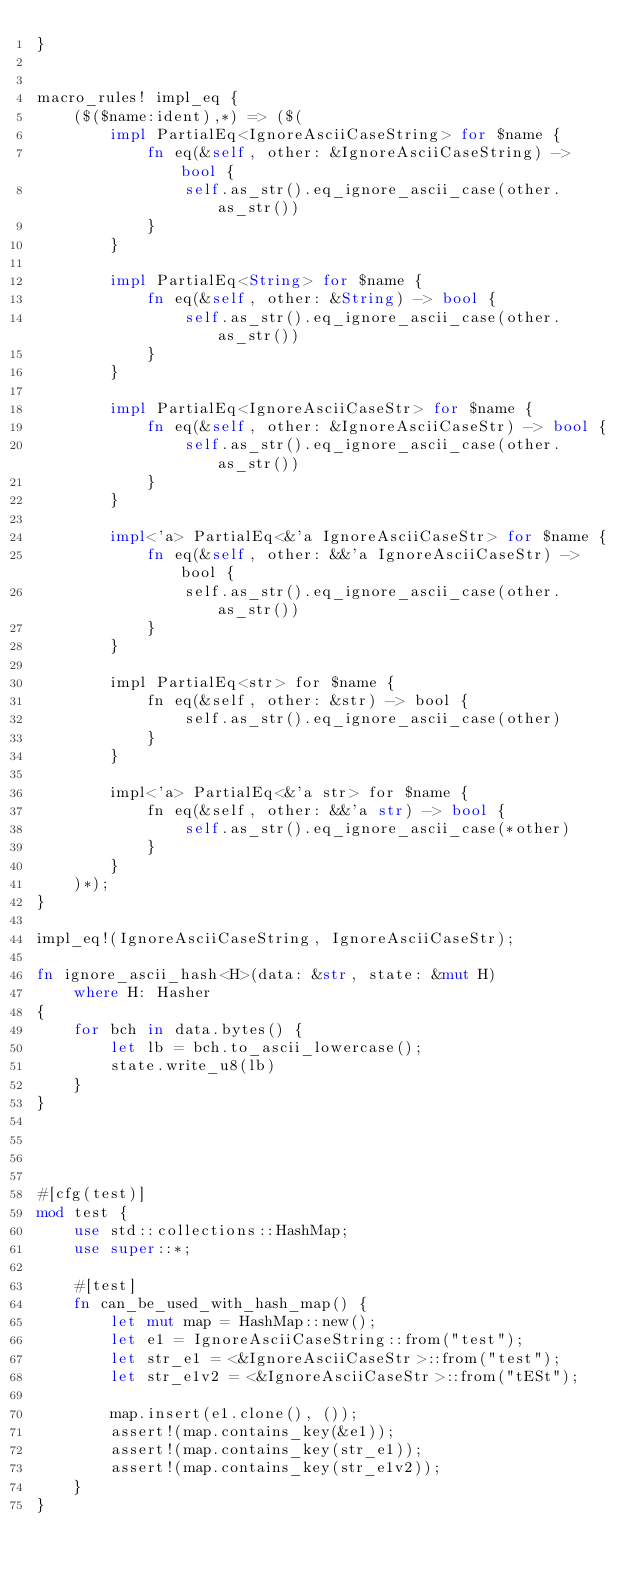Convert code to text. <code><loc_0><loc_0><loc_500><loc_500><_Rust_>}


macro_rules! impl_eq {
    ($($name:ident),*) => ($(
        impl PartialEq<IgnoreAsciiCaseString> for $name {
            fn eq(&self, other: &IgnoreAsciiCaseString) -> bool {
                self.as_str().eq_ignore_ascii_case(other.as_str())
            }
        }

        impl PartialEq<String> for $name {
            fn eq(&self, other: &String) -> bool {
                self.as_str().eq_ignore_ascii_case(other.as_str())
            }
        }

        impl PartialEq<IgnoreAsciiCaseStr> for $name {
            fn eq(&self, other: &IgnoreAsciiCaseStr) -> bool {
                self.as_str().eq_ignore_ascii_case(other.as_str())
            }
        }

        impl<'a> PartialEq<&'a IgnoreAsciiCaseStr> for $name {
            fn eq(&self, other: &&'a IgnoreAsciiCaseStr) -> bool {
                self.as_str().eq_ignore_ascii_case(other.as_str())
            }
        }

        impl PartialEq<str> for $name {
            fn eq(&self, other: &str) -> bool {
                self.as_str().eq_ignore_ascii_case(other)
            }
        }

        impl<'a> PartialEq<&'a str> for $name {
            fn eq(&self, other: &&'a str) -> bool {
                self.as_str().eq_ignore_ascii_case(*other)
            }
        }
    )*);
}

impl_eq!(IgnoreAsciiCaseString, IgnoreAsciiCaseStr);

fn ignore_ascii_hash<H>(data: &str, state: &mut H)
    where H: Hasher
{
    for bch in data.bytes() {
        let lb = bch.to_ascii_lowercase();
        state.write_u8(lb)
    }
}




#[cfg(test)]
mod test {
    use std::collections::HashMap;
    use super::*;

    #[test]
    fn can_be_used_with_hash_map() {
        let mut map = HashMap::new();
        let e1 = IgnoreAsciiCaseString::from("test");
        let str_e1 = <&IgnoreAsciiCaseStr>::from("test");
        let str_e1v2 = <&IgnoreAsciiCaseStr>::from("tESt");

        map.insert(e1.clone(), ());
        assert!(map.contains_key(&e1));
        assert!(map.contains_key(str_e1));
        assert!(map.contains_key(str_e1v2));
    }
}</code> 